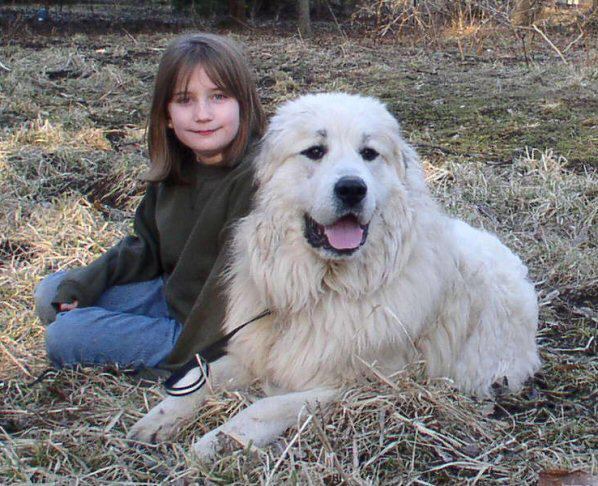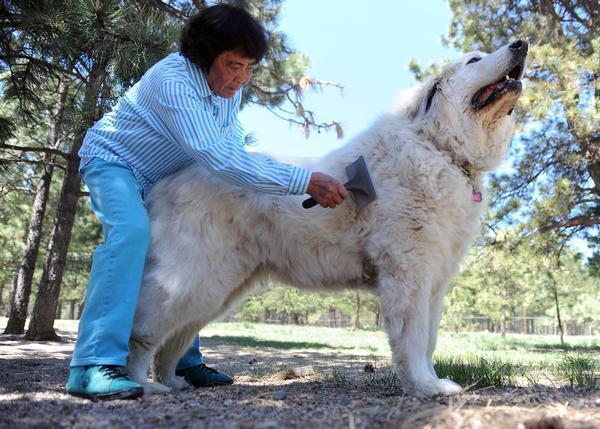The first image is the image on the left, the second image is the image on the right. Evaluate the accuracy of this statement regarding the images: "On of the images contains a young girl in a green sweater with a large white dog.". Is it true? Answer yes or no. Yes. The first image is the image on the left, the second image is the image on the right. Evaluate the accuracy of this statement regarding the images: "there is a person near a dog in the image on the right side.". Is it true? Answer yes or no. Yes. 